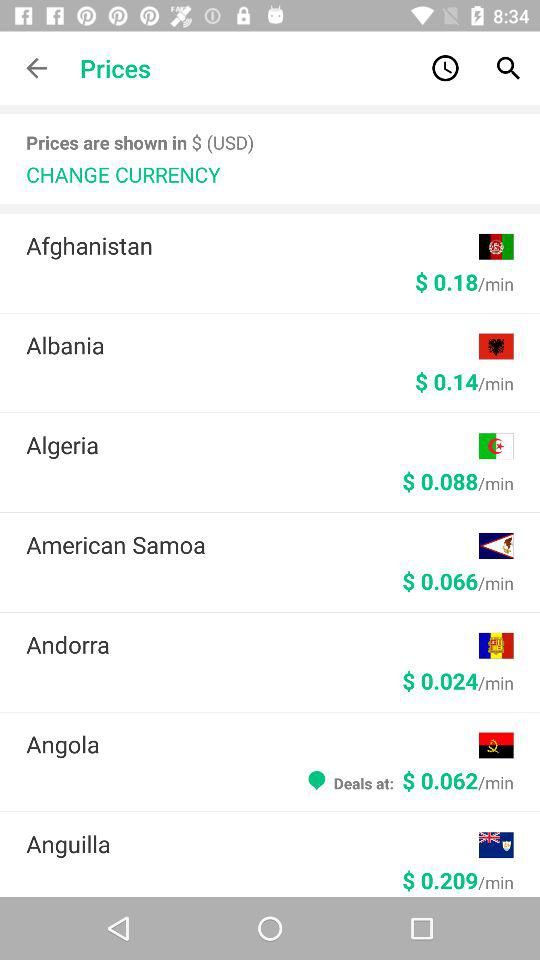What is the selected currency? The selected currency is USD. 